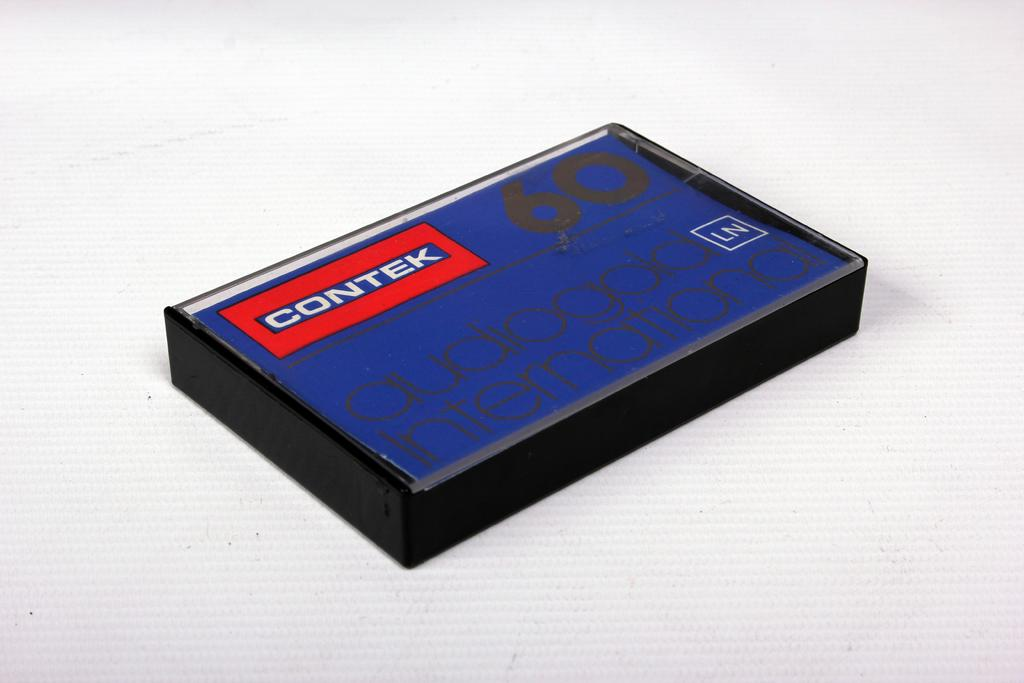<image>
Describe the image concisely. A plastic Contek audio box has the lid down. 